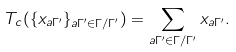<formula> <loc_0><loc_0><loc_500><loc_500>T _ { c } ( \{ x _ { a \Gamma ^ { \prime } } \} _ { a \Gamma ^ { \prime } \in \Gamma / \Gamma ^ { \prime } } ) = \sum _ { a \Gamma ^ { \prime } \in \Gamma / \Gamma ^ { \prime } } x _ { a \Gamma ^ { \prime } } .</formula> 